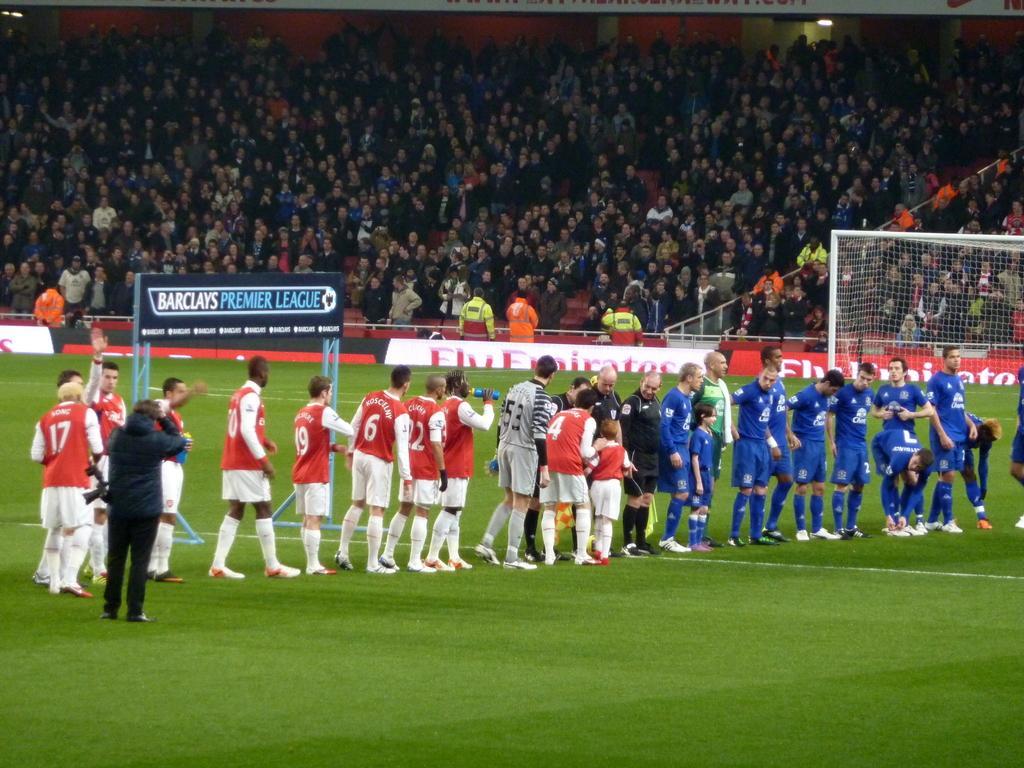Could you give a brief overview of what you see in this image? In this image, we can see a group of people are on the ground. Few people are holding some objects. In the background, we can see net, poles, hoarding, banners, crowd, wall and rods. 